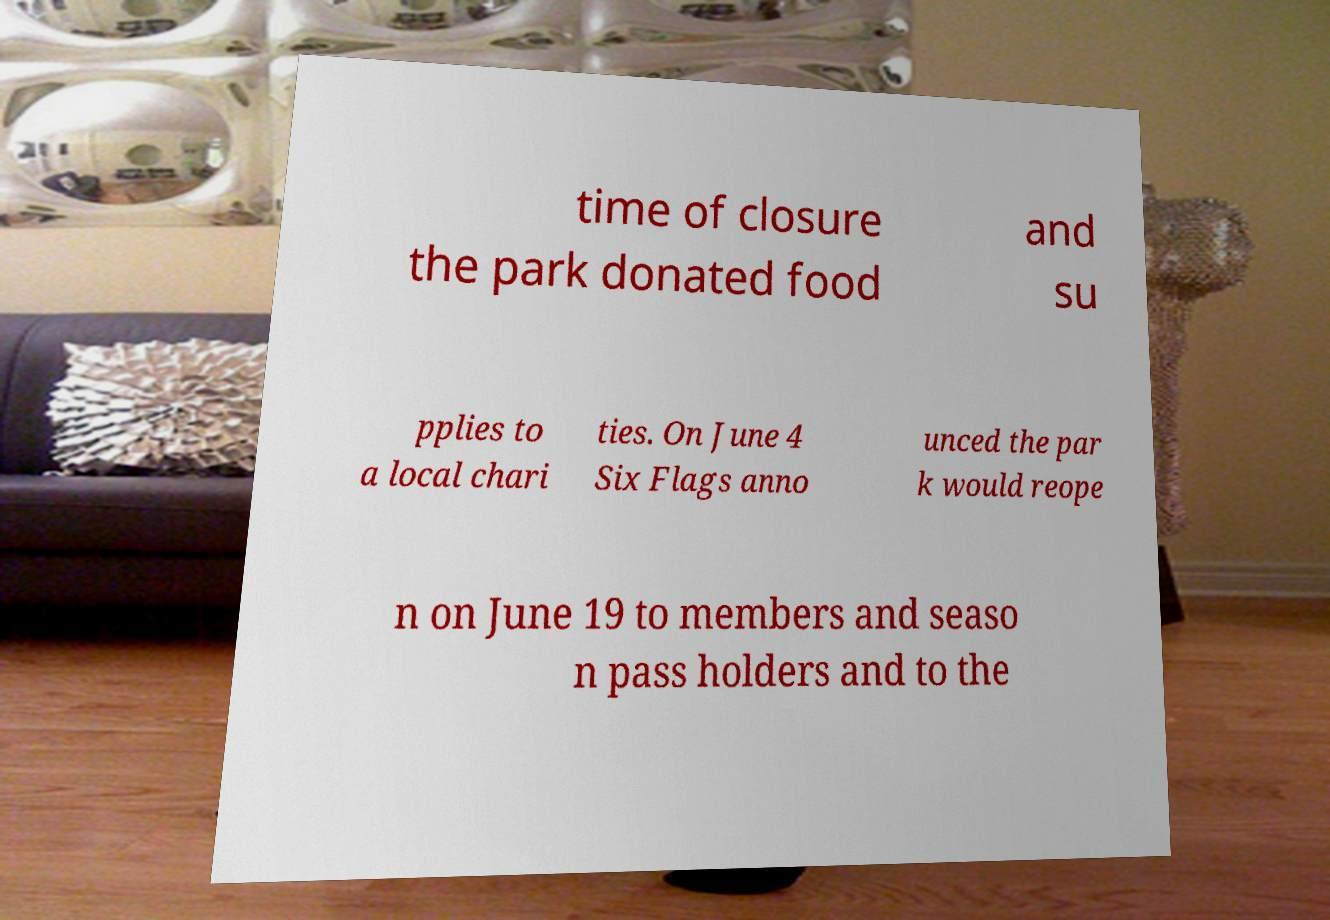Can you read and provide the text displayed in the image?This photo seems to have some interesting text. Can you extract and type it out for me? time of closure the park donated food and su pplies to a local chari ties. On June 4 Six Flags anno unced the par k would reope n on June 19 to members and seaso n pass holders and to the 